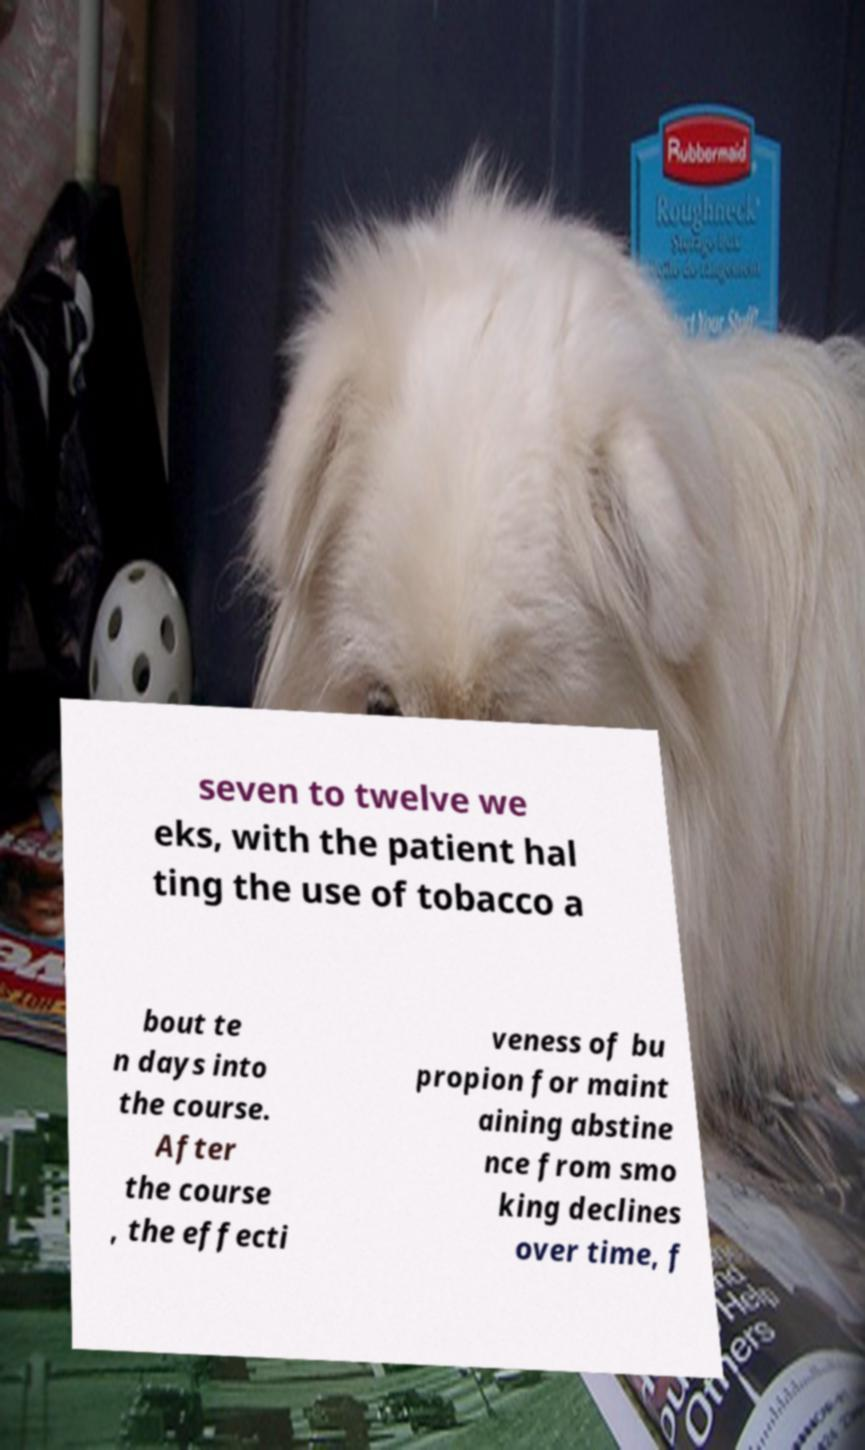Can you read and provide the text displayed in the image?This photo seems to have some interesting text. Can you extract and type it out for me? seven to twelve we eks, with the patient hal ting the use of tobacco a bout te n days into the course. After the course , the effecti veness of bu propion for maint aining abstine nce from smo king declines over time, f 